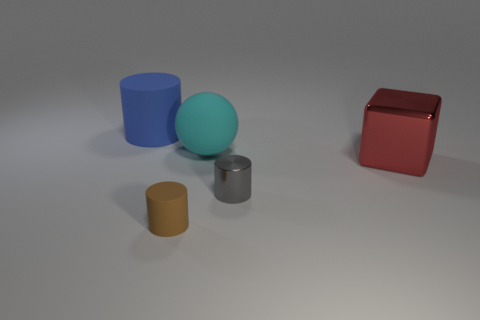Is the number of big matte balls in front of the red metallic block less than the number of big red objects?
Your answer should be compact. Yes. Is the large red cube made of the same material as the small brown thing?
Offer a very short reply. No. What number of tiny purple objects are the same material as the large block?
Ensure brevity in your answer.  0. What is the color of the large cylinder that is made of the same material as the cyan object?
Offer a very short reply. Blue. What is the shape of the brown thing?
Make the answer very short. Cylinder. What material is the tiny cylinder on the right side of the brown cylinder?
Provide a short and direct response. Metal. Are there any other big metallic blocks of the same color as the metallic block?
Your answer should be very brief. No. The red metallic object that is the same size as the blue rubber object is what shape?
Ensure brevity in your answer.  Cube. The matte cylinder in front of the large cylinder is what color?
Your answer should be compact. Brown. There is a rubber cylinder to the right of the big blue cylinder; is there a big red cube that is in front of it?
Offer a very short reply. No. 